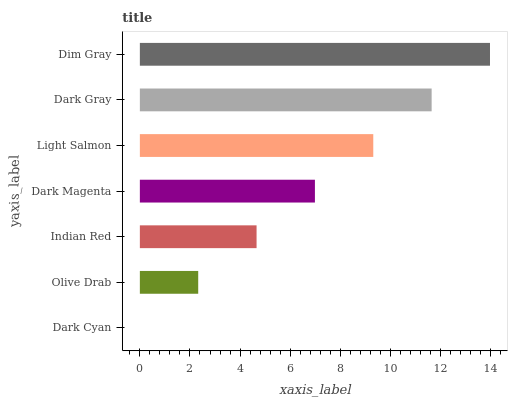Is Dark Cyan the minimum?
Answer yes or no. Yes. Is Dim Gray the maximum?
Answer yes or no. Yes. Is Olive Drab the minimum?
Answer yes or no. No. Is Olive Drab the maximum?
Answer yes or no. No. Is Olive Drab greater than Dark Cyan?
Answer yes or no. Yes. Is Dark Cyan less than Olive Drab?
Answer yes or no. Yes. Is Dark Cyan greater than Olive Drab?
Answer yes or no. No. Is Olive Drab less than Dark Cyan?
Answer yes or no. No. Is Dark Magenta the high median?
Answer yes or no. Yes. Is Dark Magenta the low median?
Answer yes or no. Yes. Is Dim Gray the high median?
Answer yes or no. No. Is Dim Gray the low median?
Answer yes or no. No. 